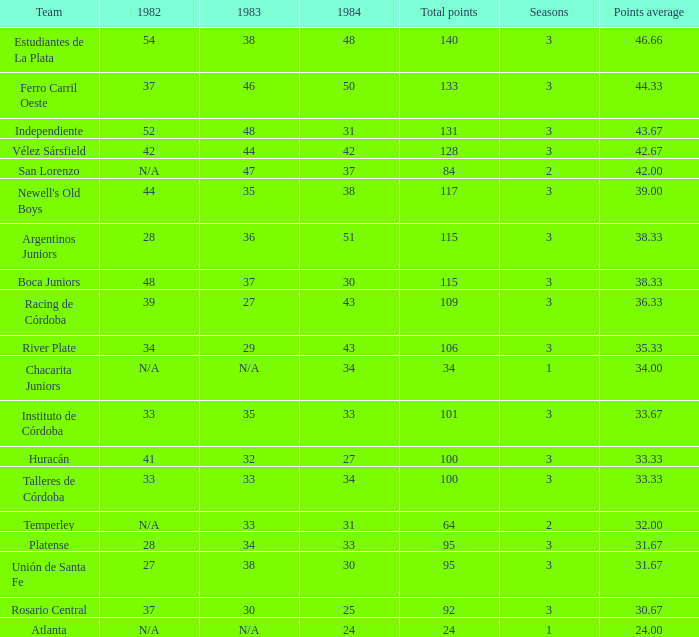What is the points total for the team with points average more than 34, 1984 score more than 37 and N/A in 1982? 0.0. 